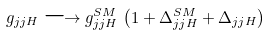<formula> <loc_0><loc_0><loc_500><loc_500>g _ { j j H } \longrightarrow g _ { j j H } ^ { S M } \, \left ( 1 + \Delta _ { j j H } ^ { S M } + \Delta _ { j j H } \right )</formula> 